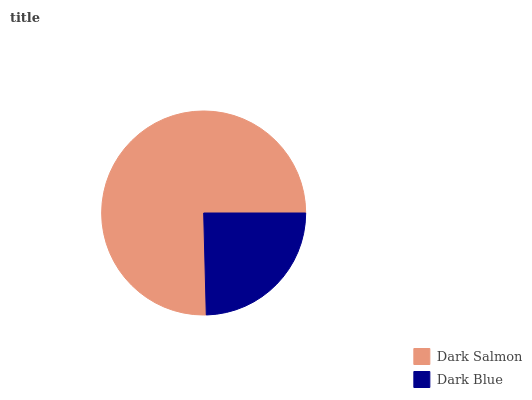Is Dark Blue the minimum?
Answer yes or no. Yes. Is Dark Salmon the maximum?
Answer yes or no. Yes. Is Dark Blue the maximum?
Answer yes or no. No. Is Dark Salmon greater than Dark Blue?
Answer yes or no. Yes. Is Dark Blue less than Dark Salmon?
Answer yes or no. Yes. Is Dark Blue greater than Dark Salmon?
Answer yes or no. No. Is Dark Salmon less than Dark Blue?
Answer yes or no. No. Is Dark Salmon the high median?
Answer yes or no. Yes. Is Dark Blue the low median?
Answer yes or no. Yes. Is Dark Blue the high median?
Answer yes or no. No. Is Dark Salmon the low median?
Answer yes or no. No. 